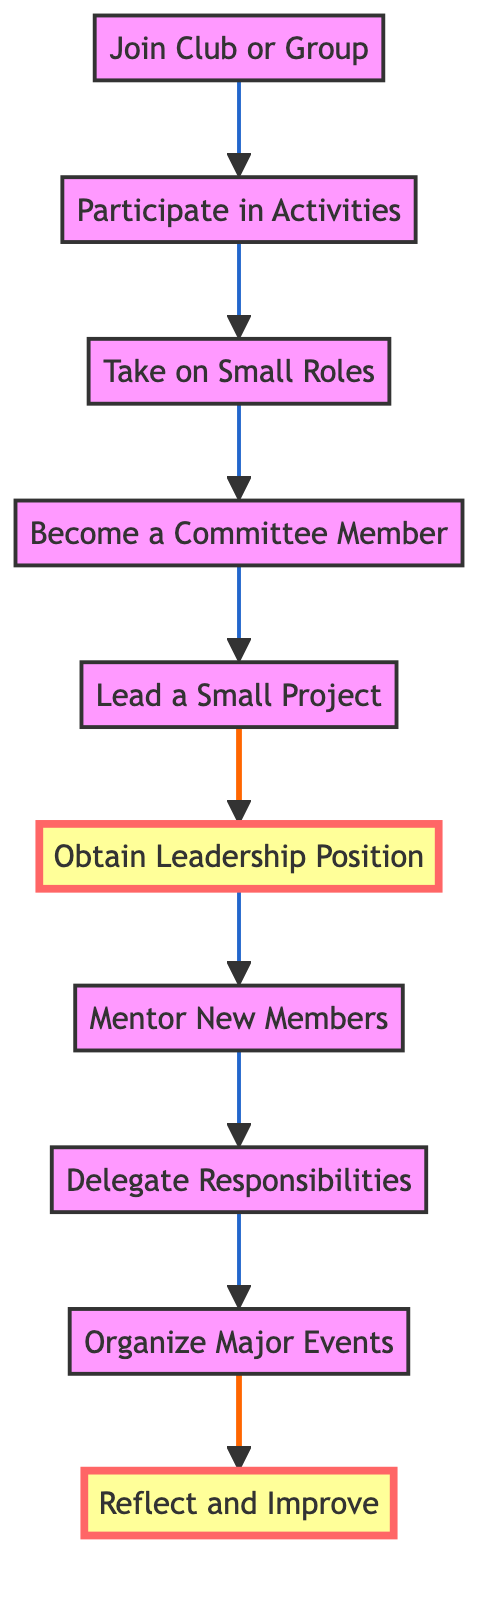What is the first step in the progression of leadership skills? The diagram indicates the first step is "Join Club or Group," which initiates the progression toward leadership skills.
Answer: Join Club or Group How many nodes are there in the diagram? By counting each unique step in the flow chart from start to finish, we find there are ten nodes illustrating the progression of leadership skills.
Answer: Ten What is the last step in the progression? The diagram shows that the final step is "Reflect and Improve," marking the conclusion of the leadership skill development process.
Answer: Reflect and Improve What is the relationship between "Become a Committee Member" and "Lead a Small Project"? "Become a Committee Member" directly precedes "Lead a Small Project" in the flow, indicating that stepping into a committee role is a prerequisite for leading small projects.
Answer: Directly precedes Which node focuses on mentorship? The node labeled "Mentor New Members" specifically addresses the act of guiding and supporting newer or younger participants in the group.
Answer: Mentor New Members What is the key responsibility involved in "Delegate Responsibilities"? This node emphasizes the importance of effectively assigning tasks to utilize team strengths and enhance collaboration among members.
Answer: Assign tasks How many steps must you complete before obtaining a leadership position? To reach "Obtain Leadership Position," a student must successfully navigate through five previous steps, from joining a group to leading a project.
Answer: Five steps What skill is developed after obtaining a leadership position? Following the attainment of a leadership position, the next focus shifts to mentoring, helping new members adjust and participate actively.
Answer: Mentor New Members Which step involves planning larger initiatives? The diagram states that "Organize Major Events" is the step where students engage in the planning and execution of significant projects or events.
Answer: Organize Major Events 